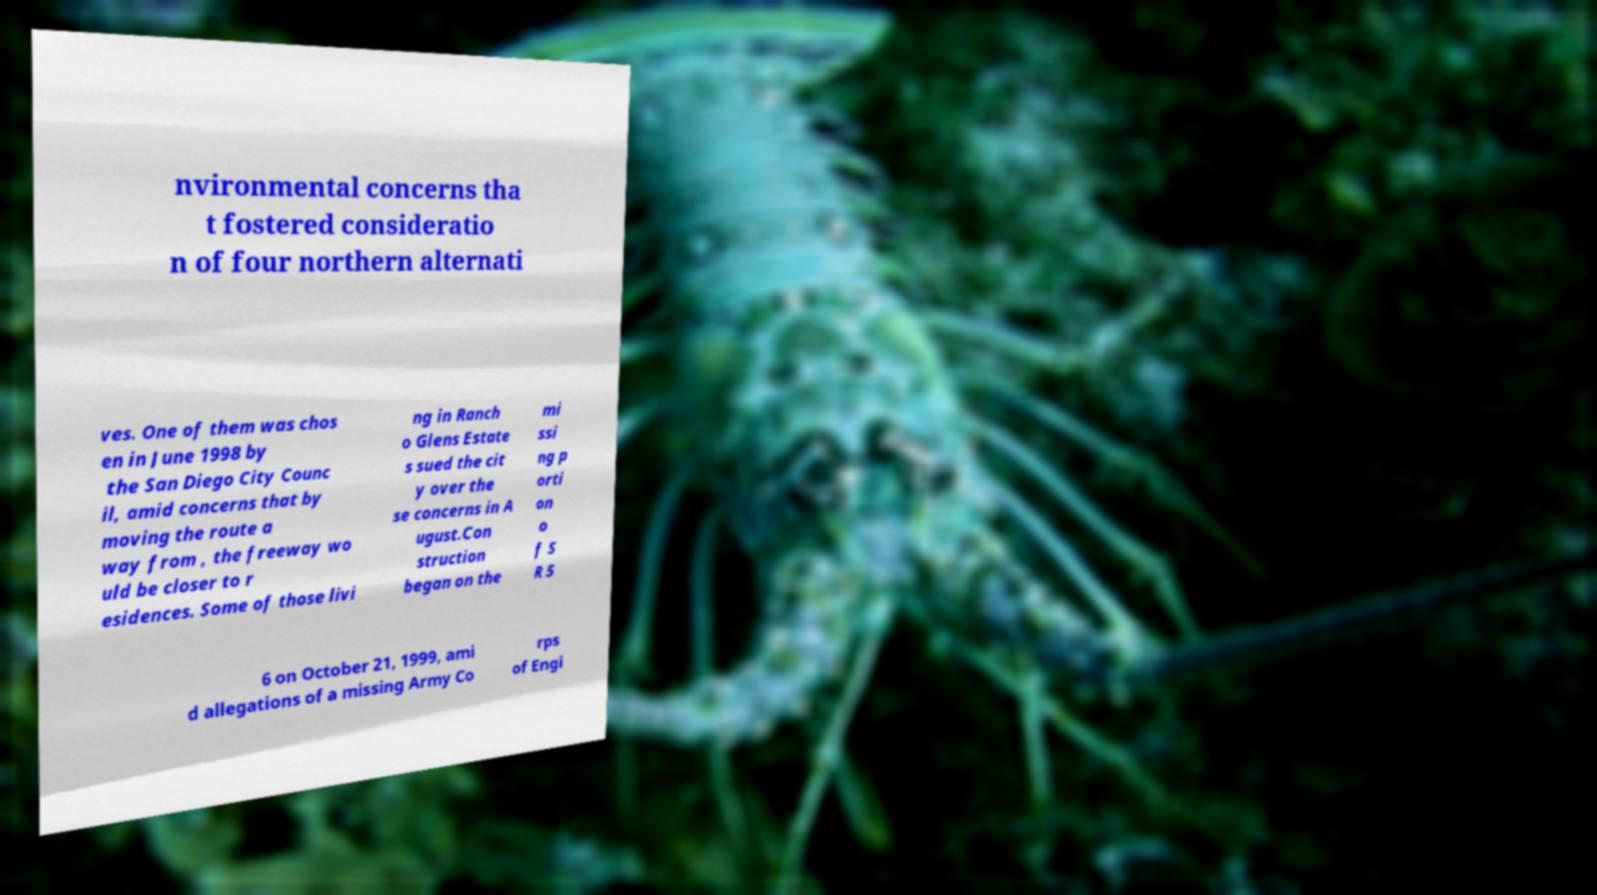I need the written content from this picture converted into text. Can you do that? nvironmental concerns tha t fostered consideratio n of four northern alternati ves. One of them was chos en in June 1998 by the San Diego City Counc il, amid concerns that by moving the route a way from , the freeway wo uld be closer to r esidences. Some of those livi ng in Ranch o Glens Estate s sued the cit y over the se concerns in A ugust.Con struction began on the mi ssi ng p orti on o f S R 5 6 on October 21, 1999, ami d allegations of a missing Army Co rps of Engi 